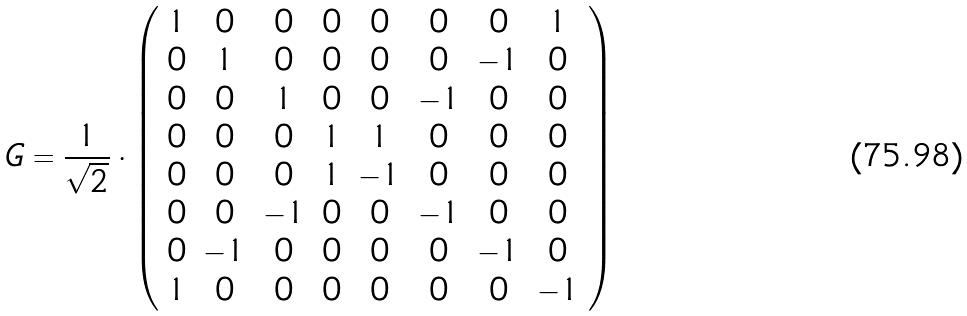<formula> <loc_0><loc_0><loc_500><loc_500>G = \frac { 1 } { \sqrt { 2 } } \cdot \left ( \begin{array} { c c c c c c c c } 1 & 0 & 0 & 0 & 0 & 0 & 0 & 1 \\ 0 & 1 & 0 & 0 & 0 & 0 & - 1 & 0 \\ 0 & 0 & 1 & 0 & 0 & - 1 & 0 & 0 \\ 0 & 0 & 0 & 1 & 1 & 0 & 0 & 0 \\ 0 & 0 & 0 & 1 & - 1 & 0 & 0 & 0 \\ 0 & 0 & - 1 & 0 & 0 & - 1 & 0 & 0 \\ 0 & - 1 & 0 & 0 & 0 & 0 & - 1 & 0 \\ 1 & 0 & 0 & 0 & 0 & 0 & 0 & - 1 \end{array} \right )</formula> 